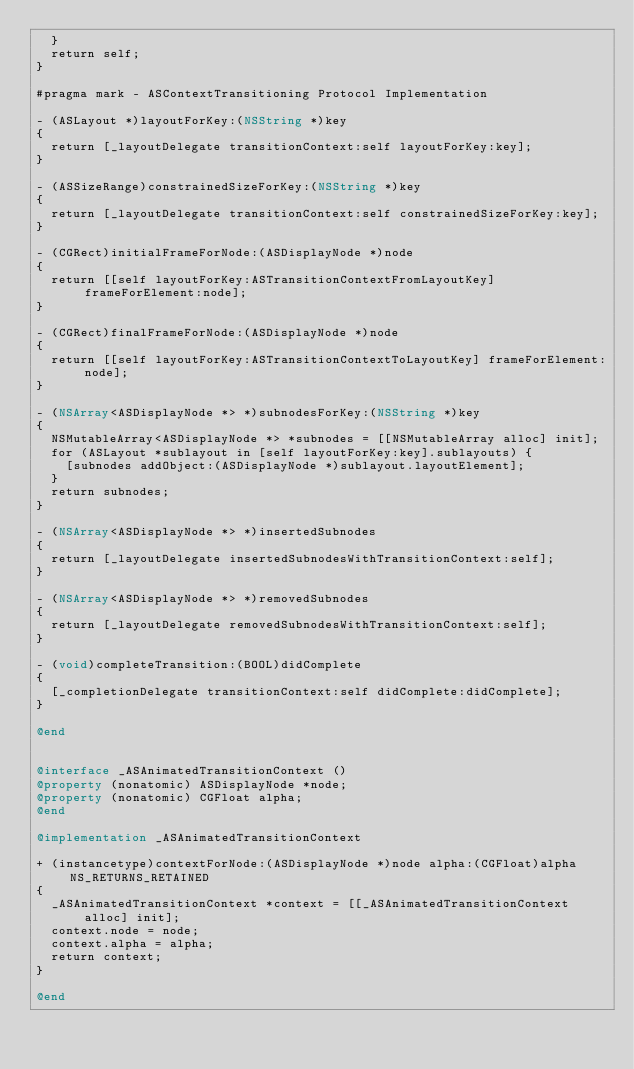Convert code to text. <code><loc_0><loc_0><loc_500><loc_500><_ObjectiveC_>  }
  return self;
}

#pragma mark - ASContextTransitioning Protocol Implementation

- (ASLayout *)layoutForKey:(NSString *)key
{
  return [_layoutDelegate transitionContext:self layoutForKey:key];
}

- (ASSizeRange)constrainedSizeForKey:(NSString *)key
{
  return [_layoutDelegate transitionContext:self constrainedSizeForKey:key];
}

- (CGRect)initialFrameForNode:(ASDisplayNode *)node
{
  return [[self layoutForKey:ASTransitionContextFromLayoutKey] frameForElement:node];
}

- (CGRect)finalFrameForNode:(ASDisplayNode *)node
{
  return [[self layoutForKey:ASTransitionContextToLayoutKey] frameForElement:node];
}

- (NSArray<ASDisplayNode *> *)subnodesForKey:(NSString *)key
{
  NSMutableArray<ASDisplayNode *> *subnodes = [[NSMutableArray alloc] init];
  for (ASLayout *sublayout in [self layoutForKey:key].sublayouts) {
    [subnodes addObject:(ASDisplayNode *)sublayout.layoutElement];
  }
  return subnodes;
}

- (NSArray<ASDisplayNode *> *)insertedSubnodes
{
  return [_layoutDelegate insertedSubnodesWithTransitionContext:self];
}

- (NSArray<ASDisplayNode *> *)removedSubnodes
{
  return [_layoutDelegate removedSubnodesWithTransitionContext:self];
}

- (void)completeTransition:(BOOL)didComplete
{
  [_completionDelegate transitionContext:self didComplete:didComplete];
}

@end


@interface _ASAnimatedTransitionContext ()
@property (nonatomic) ASDisplayNode *node;
@property (nonatomic) CGFloat alpha;
@end

@implementation _ASAnimatedTransitionContext

+ (instancetype)contextForNode:(ASDisplayNode *)node alpha:(CGFloat)alpha NS_RETURNS_RETAINED
{
  _ASAnimatedTransitionContext *context = [[_ASAnimatedTransitionContext alloc] init];
  context.node = node;
  context.alpha = alpha;
  return context;
}

@end
</code> 